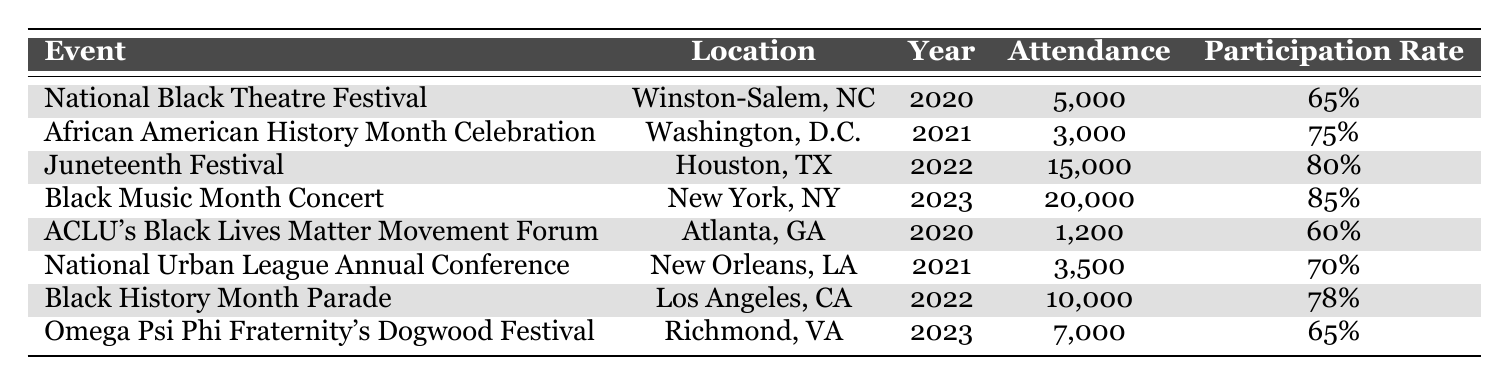What was the attendance for the Juneteenth Festival in 2022? The event name "Juneteenth Festival" corresponds to the year 2022 in the table, where the attendance listed is 15,000.
Answer: 15,000 Which event in 2021 had the highest participation rate? In 2021, the events listed are "African American History Month Celebration" with a 75% participation rate and "National Urban League Annual Conference" with a 70% participation rate. The higher participation rate is 75%, which corresponds to the "African American History Month Celebration."
Answer: African American History Month Celebration What is the total attendance for all events in 2023? The events in 2023 are "Black Music Month Concert" with an attendance of 20,000 and "Omega Psi Phi Fraternity's Dogwood Festival" with an attendance of 7,000. Adding these together (20,000 + 7,000) gives a total of 27,000.
Answer: 27,000 Did the participation rate for the National Black Theatre Festival decrease in comparison to the ACLU's Black Lives Matter Movement Forum? The National Black Theatre Festival in 2020 had a participation rate of 65%, while the ACLU's Black Lives Matter Movement Forum also in 2020 had a participation rate of 60%. Since 65% is greater than 60%, the participation rate did not decrease.
Answer: No What is the average participation rate across all events listed in 2022? The events for 2022 are the "Juneteenth Festival" with a participation rate of 80% and the "Black History Month Parade" with a participation rate of 78%. To find the average, you sum these rates (80 + 78) = 158 and then divide by the number of events (2), resulting in an average participation rate of 79%.
Answer: 79% Which event had the lowest attendance in the table? By examining the attendance figures, "ACLU's Black Lives Matter Movement Forum" has the lowest attendance of 1,200 compared to other events in the table.
Answer: ACLU's Black Lives Matter Movement Forum In which year was the National Urban League Annual Conference held, and what was its attendance? The National Urban League Annual Conference is listed for the year 2021, with an attendance of 3,500 as provided in the table.
Answer: 2021, 3,500 What is the difference in attendance between the Black Music Month Concert and the National Black Theatre Festival? The Black Music Month Concert had an attendance of 20,000 and the National Black Theatre Festival had an attendance of 5,000. The difference in attendance is calculated by subtracting (20,000 - 5,000) which equals 15,000.
Answer: 15,000 If you consider the participation rates of all events in 2020, what was the average participation rate? In 2020, the events are the "National Black Theatre Festival" with a participation rate of 65% and "ACLU's Black Lives Matter Movement Forum" with 60%. Adding the two rates (65 + 60) equals 125, and dividing by 2 for the average gives 62.5%.
Answer: 62.5% 